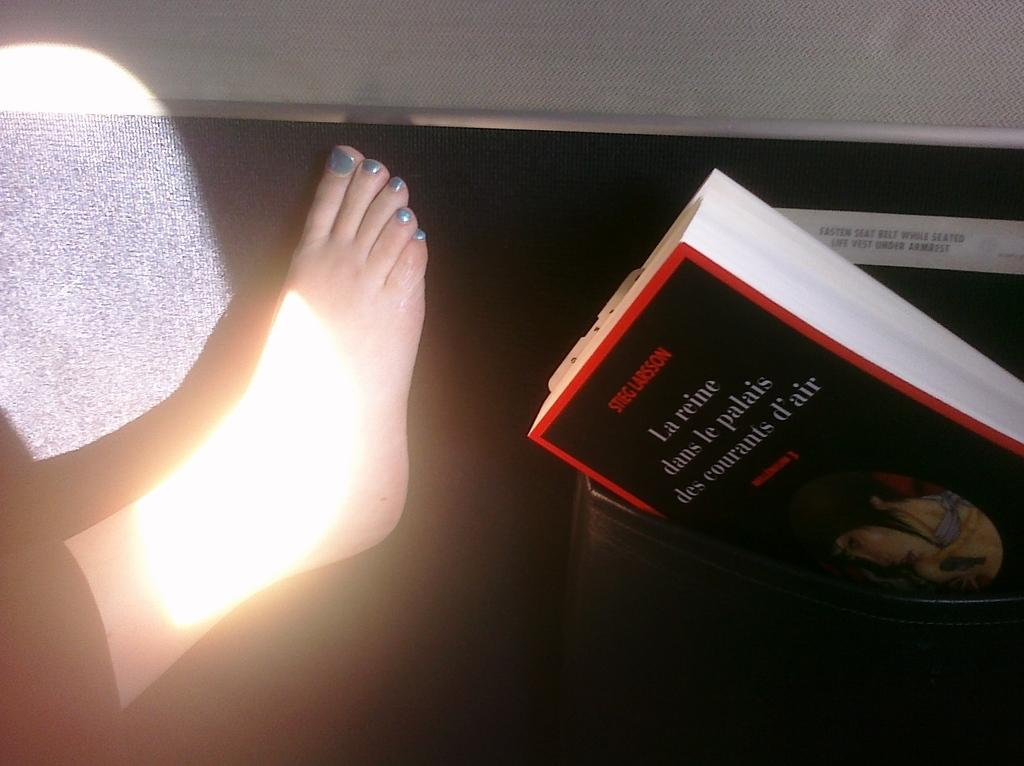<image>
Write a terse but informative summary of the picture. A foot next to the book La reine dans le palais des courants d'air. 